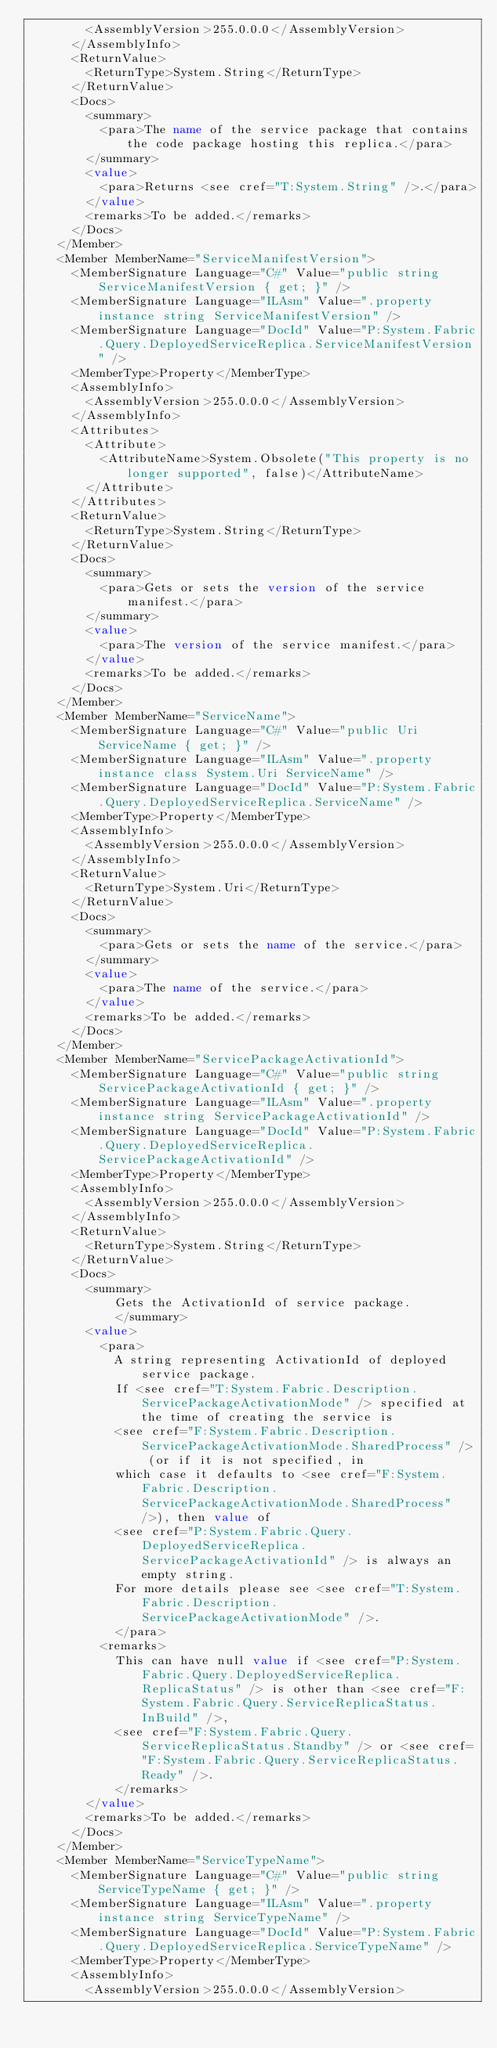<code> <loc_0><loc_0><loc_500><loc_500><_XML_>        <AssemblyVersion>255.0.0.0</AssemblyVersion>
      </AssemblyInfo>
      <ReturnValue>
        <ReturnType>System.String</ReturnType>
      </ReturnValue>
      <Docs>
        <summary>
          <para>The name of the service package that contains the code package hosting this replica.</para>
        </summary>
        <value>
          <para>Returns <see cref="T:System.String" />.</para>
        </value>
        <remarks>To be added.</remarks>
      </Docs>
    </Member>
    <Member MemberName="ServiceManifestVersion">
      <MemberSignature Language="C#" Value="public string ServiceManifestVersion { get; }" />
      <MemberSignature Language="ILAsm" Value=".property instance string ServiceManifestVersion" />
      <MemberSignature Language="DocId" Value="P:System.Fabric.Query.DeployedServiceReplica.ServiceManifestVersion" />
      <MemberType>Property</MemberType>
      <AssemblyInfo>
        <AssemblyVersion>255.0.0.0</AssemblyVersion>
      </AssemblyInfo>
      <Attributes>
        <Attribute>
          <AttributeName>System.Obsolete("This property is no longer supported", false)</AttributeName>
        </Attribute>
      </Attributes>
      <ReturnValue>
        <ReturnType>System.String</ReturnType>
      </ReturnValue>
      <Docs>
        <summary>
          <para>Gets or sets the version of the service manifest.</para>
        </summary>
        <value>
          <para>The version of the service manifest.</para>
        </value>
        <remarks>To be added.</remarks>
      </Docs>
    </Member>
    <Member MemberName="ServiceName">
      <MemberSignature Language="C#" Value="public Uri ServiceName { get; }" />
      <MemberSignature Language="ILAsm" Value=".property instance class System.Uri ServiceName" />
      <MemberSignature Language="DocId" Value="P:System.Fabric.Query.DeployedServiceReplica.ServiceName" />
      <MemberType>Property</MemberType>
      <AssemblyInfo>
        <AssemblyVersion>255.0.0.0</AssemblyVersion>
      </AssemblyInfo>
      <ReturnValue>
        <ReturnType>System.Uri</ReturnType>
      </ReturnValue>
      <Docs>
        <summary>
          <para>Gets or sets the name of the service.</para>
        </summary>
        <value>
          <para>The name of the service.</para>
        </value>
        <remarks>To be added.</remarks>
      </Docs>
    </Member>
    <Member MemberName="ServicePackageActivationId">
      <MemberSignature Language="C#" Value="public string ServicePackageActivationId { get; }" />
      <MemberSignature Language="ILAsm" Value=".property instance string ServicePackageActivationId" />
      <MemberSignature Language="DocId" Value="P:System.Fabric.Query.DeployedServiceReplica.ServicePackageActivationId" />
      <MemberType>Property</MemberType>
      <AssemblyInfo>
        <AssemblyVersion>255.0.0.0</AssemblyVersion>
      </AssemblyInfo>
      <ReturnValue>
        <ReturnType>System.String</ReturnType>
      </ReturnValue>
      <Docs>
        <summary>
            Gets the ActivationId of service package.
            </summary>
        <value>
          <para>
            A string representing ActivationId of deployed service package. 
            If <see cref="T:System.Fabric.Description.ServicePackageActivationMode" /> specified at the time of creating the service is 
            <see cref="F:System.Fabric.Description.ServicePackageActivationMode.SharedProcess" /> (or if it is not specified, in
            which case it defaults to <see cref="F:System.Fabric.Description.ServicePackageActivationMode.SharedProcess" />), then value of 
            <see cref="P:System.Fabric.Query.DeployedServiceReplica.ServicePackageActivationId" /> is always an empty string.
            For more details please see <see cref="T:System.Fabric.Description.ServicePackageActivationMode" />.
            </para>
          <remarks>
            This can have null value if <see cref="P:System.Fabric.Query.DeployedServiceReplica.ReplicaStatus" /> is other than <see cref="F:System.Fabric.Query.ServiceReplicaStatus.InBuild" />,
            <see cref="F:System.Fabric.Query.ServiceReplicaStatus.Standby" /> or <see cref="F:System.Fabric.Query.ServiceReplicaStatus.Ready" />.
            </remarks>
        </value>
        <remarks>To be added.</remarks>
      </Docs>
    </Member>
    <Member MemberName="ServiceTypeName">
      <MemberSignature Language="C#" Value="public string ServiceTypeName { get; }" />
      <MemberSignature Language="ILAsm" Value=".property instance string ServiceTypeName" />
      <MemberSignature Language="DocId" Value="P:System.Fabric.Query.DeployedServiceReplica.ServiceTypeName" />
      <MemberType>Property</MemberType>
      <AssemblyInfo>
        <AssemblyVersion>255.0.0.0</AssemblyVersion></code> 